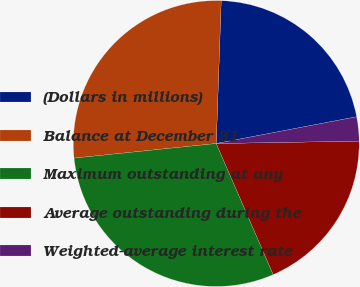<chart> <loc_0><loc_0><loc_500><loc_500><pie_chart><fcel>(Dollars in millions)<fcel>Balance at December 31<fcel>Maximum outstanding at any<fcel>Average outstanding during the<fcel>Weighted-average interest rate<nl><fcel>21.45%<fcel>27.18%<fcel>29.9%<fcel>18.74%<fcel>2.73%<nl></chart> 